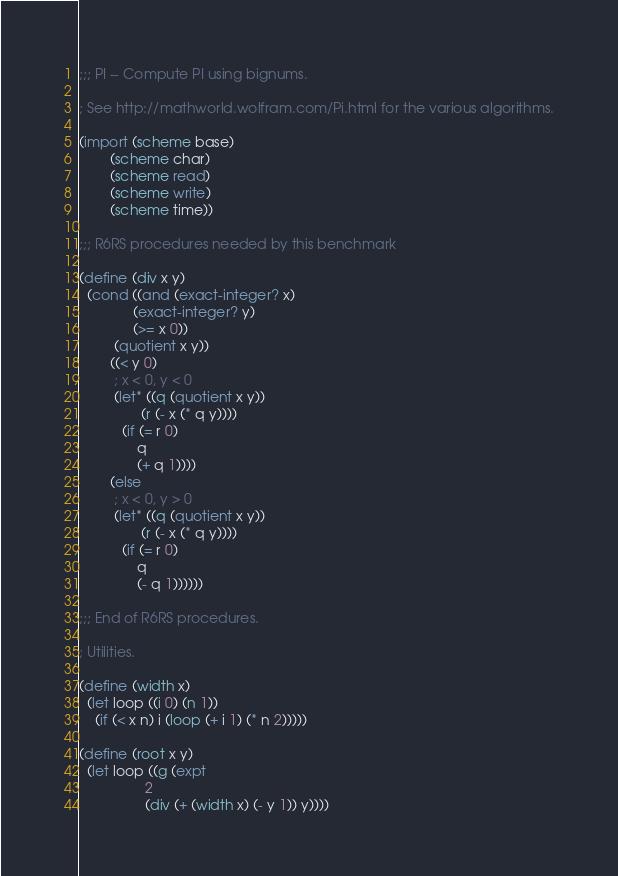Convert code to text. <code><loc_0><loc_0><loc_500><loc_500><_Scheme_>;;; PI -- Compute PI using bignums.

; See http://mathworld.wolfram.com/Pi.html for the various algorithms.

(import (scheme base)
        (scheme char)
        (scheme read)
        (scheme write)
        (scheme time))

;;; R6RS procedures needed by this benchmark

(define (div x y)
  (cond ((and (exact-integer? x)
              (exact-integer? y)
              (>= x 0))
         (quotient x y))
        ((< y 0)
         ; x < 0, y < 0
         (let* ((q (quotient x y))
                (r (- x (* q y))))
           (if (= r 0)
               q
               (+ q 1))))
        (else
         ; x < 0, y > 0
         (let* ((q (quotient x y))
                (r (- x (* q y))))
           (if (= r 0)
               q
               (- q 1))))))

;;; End of R6RS procedures.

; Utilities.

(define (width x)
  (let loop ((i 0) (n 1))
    (if (< x n) i (loop (+ i 1) (* n 2)))))

(define (root x y)
  (let loop ((g (expt
                 2
                 (div (+ (width x) (- y 1)) y))))</code> 